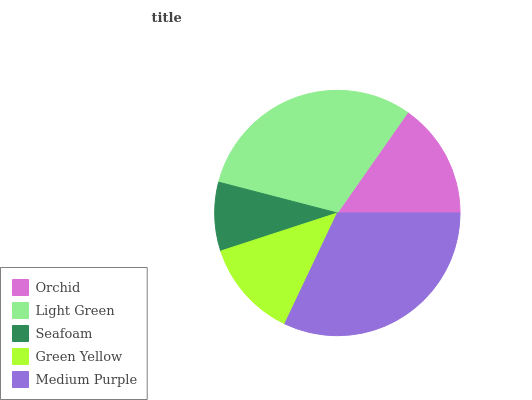Is Seafoam the minimum?
Answer yes or no. Yes. Is Medium Purple the maximum?
Answer yes or no. Yes. Is Light Green the minimum?
Answer yes or no. No. Is Light Green the maximum?
Answer yes or no. No. Is Light Green greater than Orchid?
Answer yes or no. Yes. Is Orchid less than Light Green?
Answer yes or no. Yes. Is Orchid greater than Light Green?
Answer yes or no. No. Is Light Green less than Orchid?
Answer yes or no. No. Is Orchid the high median?
Answer yes or no. Yes. Is Orchid the low median?
Answer yes or no. Yes. Is Light Green the high median?
Answer yes or no. No. Is Light Green the low median?
Answer yes or no. No. 